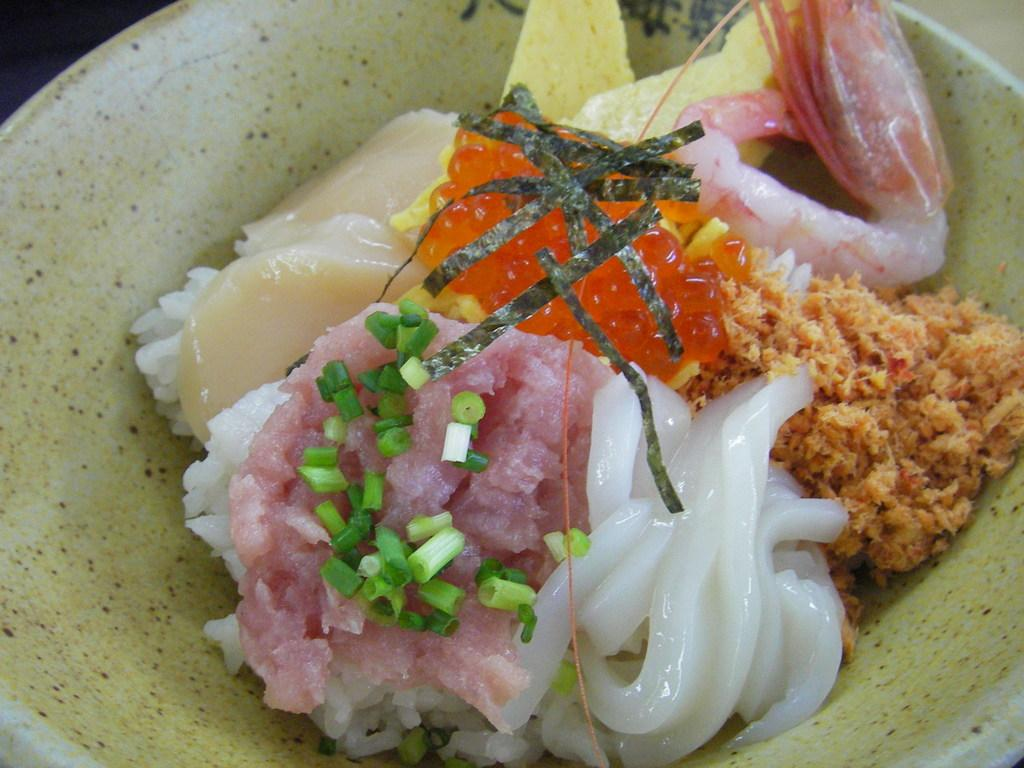What is in the bowl that is visible in the image? There is food in the bowl in the image. Can you describe the colors of the food in the bowl? The food has various colors: brown, white, green, orange, and cream. What color is the bowl itself? The bowl is white. How does the person in the image say good-bye to the chair? There is no person present in the image, and therefore no interaction with a chair or any good-bye gesture can be observed. 